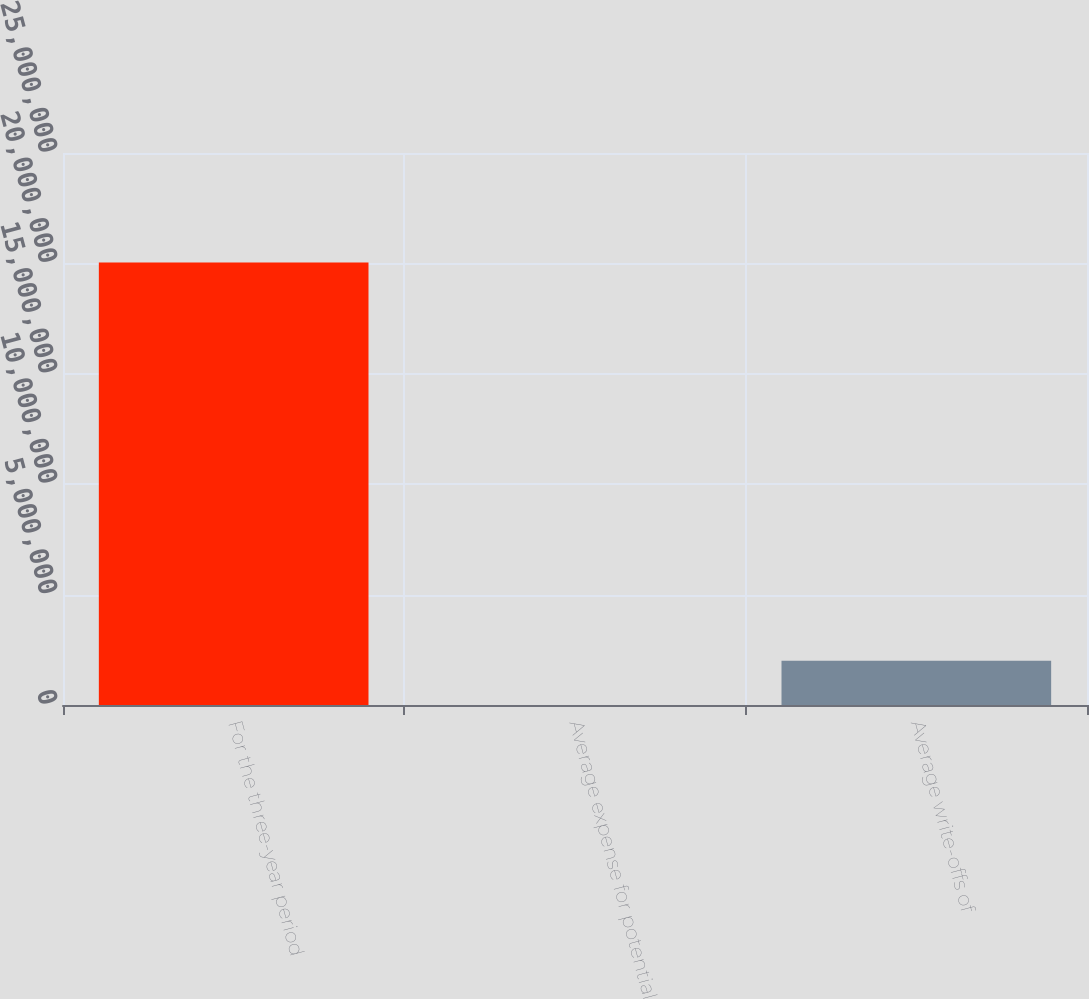<chart> <loc_0><loc_0><loc_500><loc_500><bar_chart><fcel>For the three-year period<fcel>Average expense for potential<fcel>Average write-offs of<nl><fcel>2.0042e+07<fcel>0.8<fcel>2.0042e+06<nl></chart> 